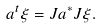Convert formula to latex. <formula><loc_0><loc_0><loc_500><loc_500>a ^ { t } \xi = J a ^ { \ast } J \xi .</formula> 